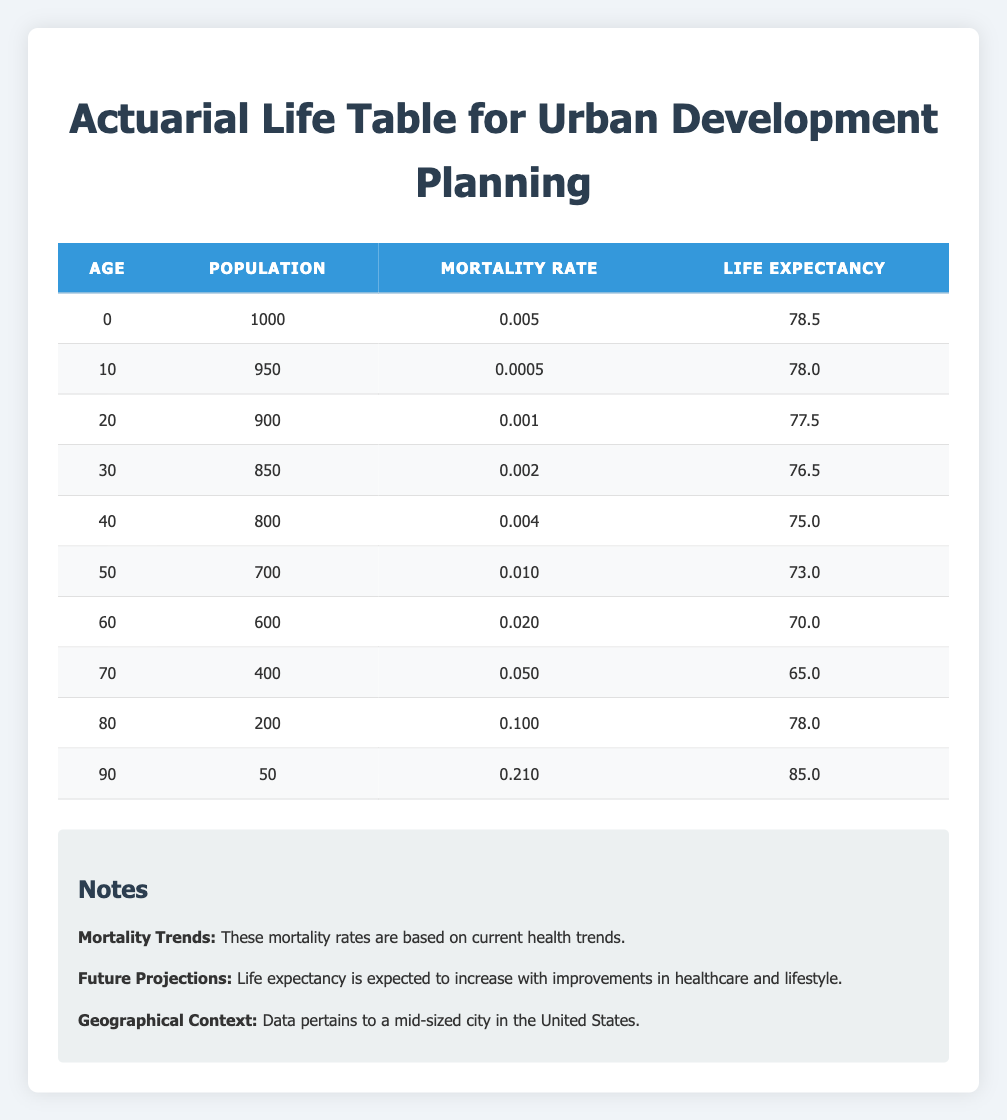What is the life expectancy for residents aged 60? Looking at the row for age 60, the life expectancy listed is 70.0 years.
Answer: 70.0 What is the population of residents aged 80? The table indicates that there are 200 residents aged 80.
Answer: 200 Is the mortality rate at age 40 higher than at age 30? The mortality rate for age 40 is 0.004, while for age 30 it is 0.002. Since 0.004 is greater than 0.002, the statement is true.
Answer: Yes What is the average life expectancy between ages 0 and 10? The life expectancies for ages 0 and 10 are 78.5 and 78.0, respectively. To find the average, sum them (78.5 + 78.0 = 156.5) and divide by 2, resulting in an average of 78.25.
Answer: 78.25 How many residents are there aged 50 and older combined? The ages 50, 60, 70, 80, and 90 have populations of 700, 600, 400, 200, and 50, respectively. Summing these populations (700 + 600 + 400 + 200 + 50 = 1950) gives a total of 1950 residents aged 50 and older.
Answer: 1950 What is the difference in life expectancy between residents aged 70 and those aged 90? The life expectancy for age 70 is 65.0 years, and for age 90, it is 85.0 years. The difference is calculated as 85.0 - 65.0 = 20.0 years.
Answer: 20.0 Is there a higher mortality rate at age 80 compared to age 70? The mortality rate for age 80 is 0.100, while for age 70, it is 0.050. Since 0.100 is greater than 0.050, the statement is true.
Answer: Yes What is the total population of all age groups in the table? The populations listed for each age group are 1000, 950, 900, 850, 800, 700, 600, 400, 200, and 50. Summing these populations (1000 + 950 + 900 + 850 + 800 + 700 + 600 + 400 + 200 + 50) results in a total population of 5,500.
Answer: 5500 How many age groups have a life expectancy below 75 years? The ages with life expectancies below 75 are 50 (73.0), 60 (70.0), 70 (65.0). This totals to three age groups: 50, 60, and 70.
Answer: 3 